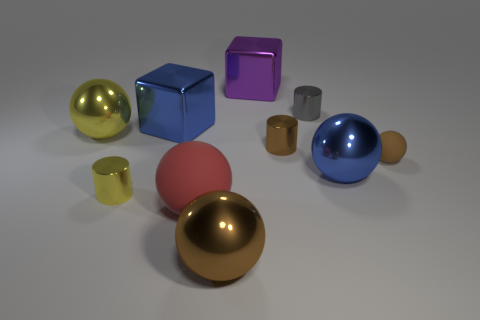Subtract all brown metallic balls. How many balls are left? 4 Subtract all red spheres. How many spheres are left? 4 Subtract all purple spheres. Subtract all purple cylinders. How many spheres are left? 5 Subtract all cubes. How many objects are left? 8 Add 10 purple shiny cylinders. How many purple shiny cylinders exist? 10 Subtract 0 red cylinders. How many objects are left? 10 Subtract all big cubes. Subtract all big red matte objects. How many objects are left? 7 Add 2 small brown matte objects. How many small brown matte objects are left? 3 